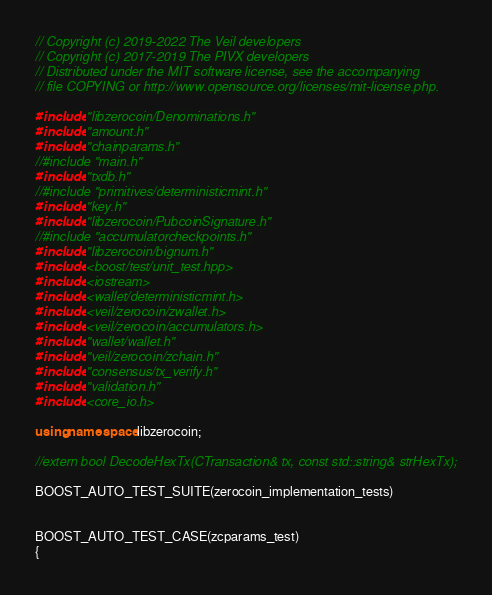Convert code to text. <code><loc_0><loc_0><loc_500><loc_500><_C++_>// Copyright (c) 2019-2022 The Veil developers
// Copyright (c) 2017-2019 The PIVX developers
// Distributed under the MIT software license, see the accompanying
// file COPYING or http://www.opensource.org/licenses/mit-license.php.

#include "libzerocoin/Denominations.h"
#include "amount.h"
#include "chainparams.h"
//#include "main.h"
#include "txdb.h"
//#include "primitives/deterministicmint.h"
#include "key.h"
#include "libzerocoin/PubcoinSignature.h"
//#include "accumulatorcheckpoints.h"
#include "libzerocoin/bignum.h"
#include <boost/test/unit_test.hpp>
#include <iostream>
#include <wallet/deterministicmint.h>
#include <veil/zerocoin/zwallet.h>
#include <veil/zerocoin/accumulators.h>
#include "wallet/wallet.h"
#include "veil/zerocoin/zchain.h"
#include "consensus/tx_verify.h"
#include "validation.h"
#include <core_io.h>

using namespace libzerocoin;

//extern bool DecodeHexTx(CTransaction& tx, const std::string& strHexTx);

BOOST_AUTO_TEST_SUITE(zerocoin_implementation_tests)


BOOST_AUTO_TEST_CASE(zcparams_test)
{</code> 